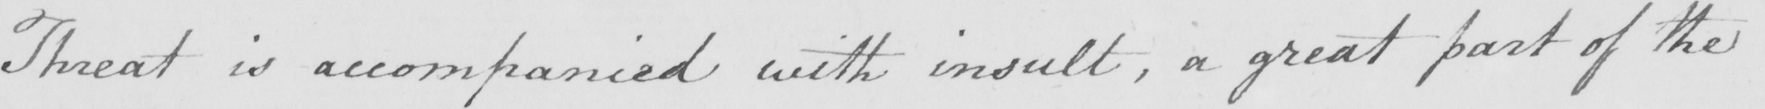Please provide the text content of this handwritten line. Threat is accompanied with insult , a great part of the 